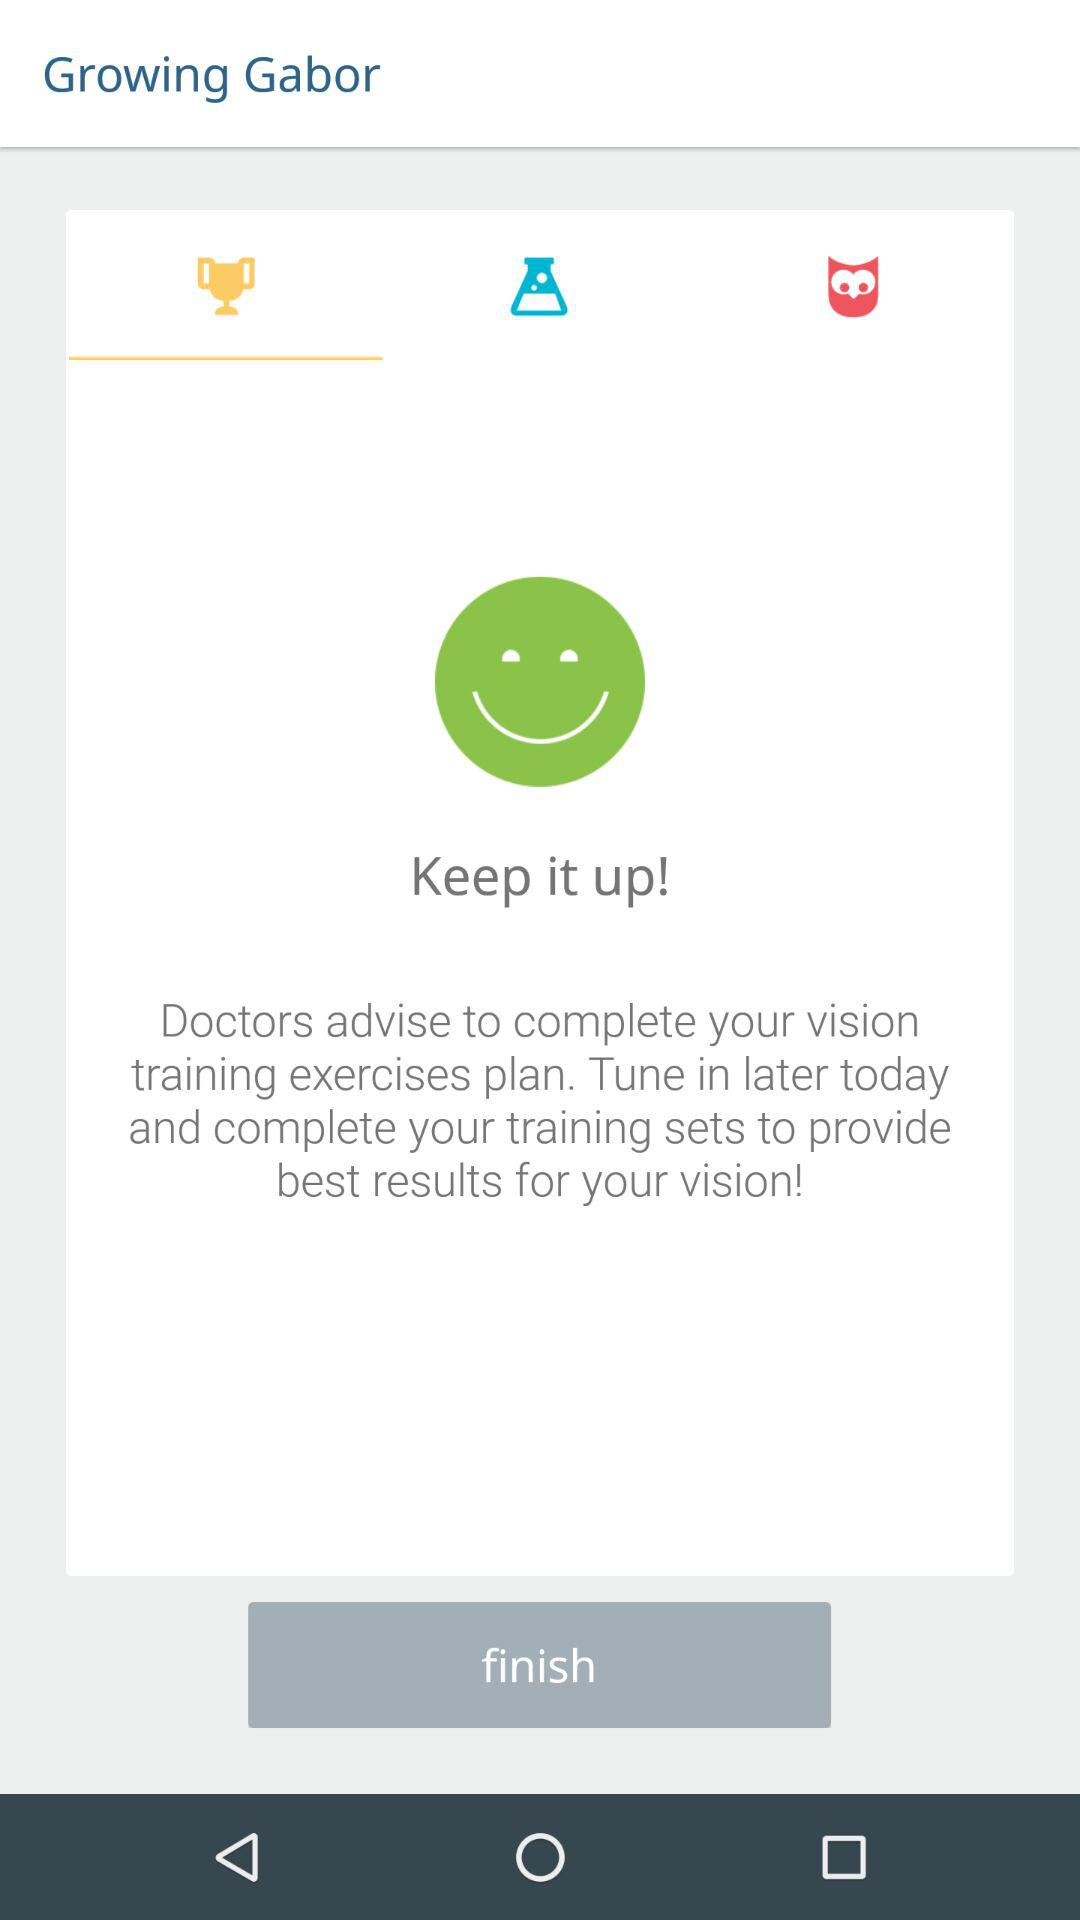What is the name of the application? The name of the application is "Growing Gabor". 